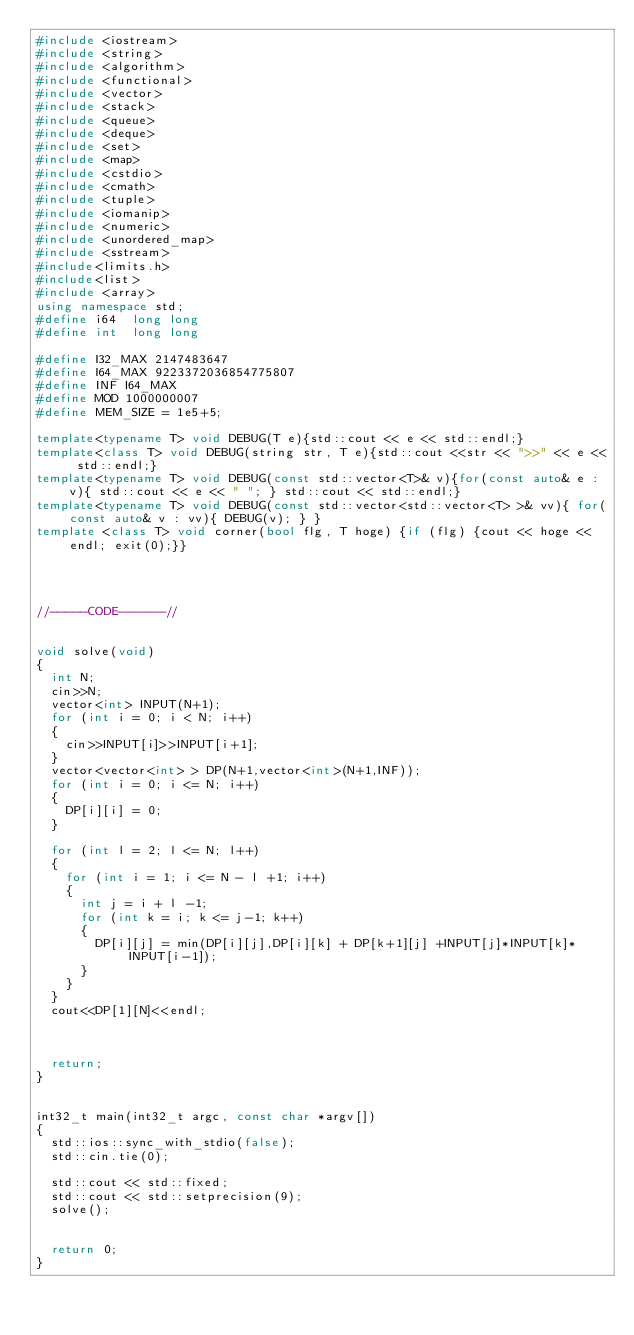<code> <loc_0><loc_0><loc_500><loc_500><_C++_>#include <iostream>
#include <string>
#include <algorithm>
#include <functional>
#include <vector>
#include <stack>
#include <queue>
#include <deque>
#include <set>
#include <map>
#include <cstdio>
#include <cmath>
#include <tuple>
#include <iomanip>
#include <numeric>
#include <unordered_map>
#include <sstream>   
#include<limits.h>
#include<list>
#include <array>
using namespace std;
#define i64  long long
#define int  long long
 
#define I32_MAX 2147483647
#define I64_MAX 9223372036854775807
#define INF I64_MAX
#define MOD 1000000007
#define MEM_SIZE = 1e5+5;

template<typename T> void DEBUG(T e){std::cout << e << std::endl;}
template<class T> void DEBUG(string str, T e){std::cout <<str << ">>" << e << std::endl;}
template<typename T> void DEBUG(const std::vector<T>& v){for(const auto& e : v){ std::cout << e << " "; } std::cout << std::endl;}
template<typename T> void DEBUG(const std::vector<std::vector<T> >& vv){ for(const auto& v : vv){ DEBUG(v); } }
template <class T> void corner(bool flg, T hoge) {if (flg) {cout << hoge << endl; exit(0);}}




//-----CODE------//


void solve(void)
{
  int N;
  cin>>N;
  vector<int> INPUT(N+1);
  for (int i = 0; i < N; i++)
  {
    cin>>INPUT[i]>>INPUT[i+1];
  }
  vector<vector<int> > DP(N+1,vector<int>(N+1,INF));
  for (int i = 0; i <= N; i++)
  {
    DP[i][i] = 0;
  }

  for (int l = 2; l <= N; l++)
  {
    for (int i = 1; i <= N - l +1; i++)
    {
      int j = i + l -1;
      for (int k = i; k <= j-1; k++)
      {
        DP[i][j] = min(DP[i][j],DP[i][k] + DP[k+1][j] +INPUT[j]*INPUT[k]*INPUT[i-1]);
      }
    }
  }
  cout<<DP[1][N]<<endl;
  
  
  
  return; 
}


int32_t main(int32_t argc, const char *argv[])
{
  std::ios::sync_with_stdio(false);
  std::cin.tie(0);

  std::cout << std::fixed;
  std::cout << std::setprecision(9);
  solve();

 
  return 0;
}
</code> 